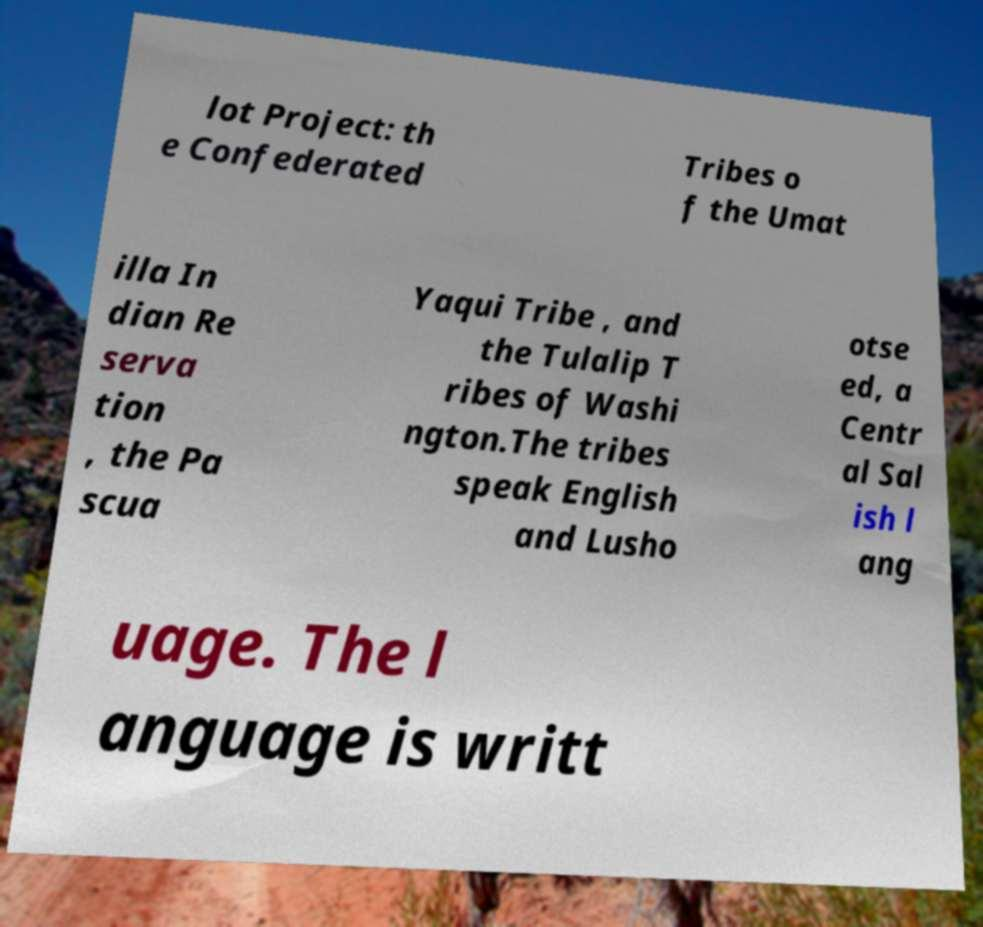Could you extract and type out the text from this image? lot Project: th e Confederated Tribes o f the Umat illa In dian Re serva tion , the Pa scua Yaqui Tribe , and the Tulalip T ribes of Washi ngton.The tribes speak English and Lusho otse ed, a Centr al Sal ish l ang uage. The l anguage is writt 